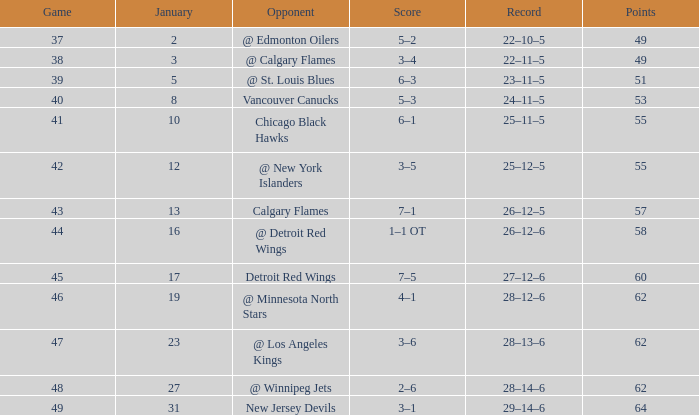What is the number of games that have a 2-6 score and more than 62 points? 0.0. 